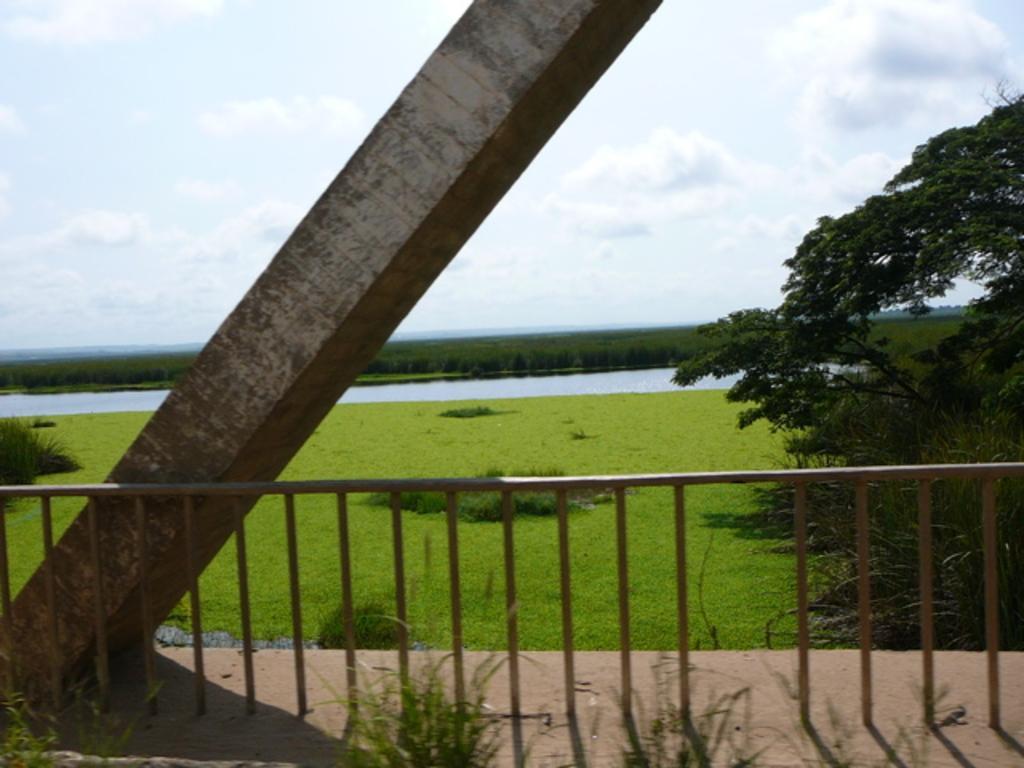Describe this image in one or two sentences. In this image I can see trees,pillar,fencing and water. The sky is in white and blue color. 